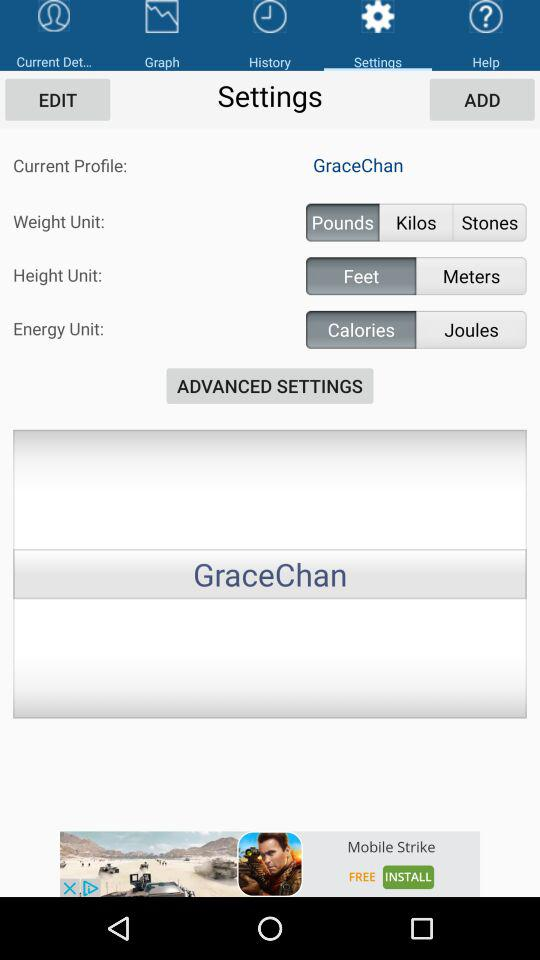What is the unit of energy? The unit of energy is calories. 